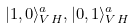<formula> <loc_0><loc_0><loc_500><loc_500>| 1 , 0 \rangle _ { V H } ^ { a } , | 0 , 1 \rangle _ { V H } ^ { a }</formula> 